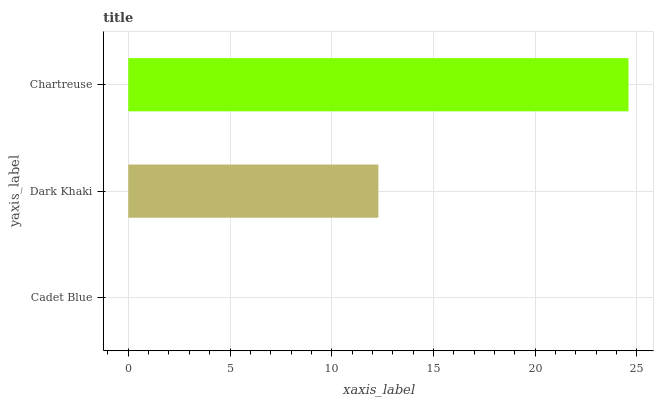Is Cadet Blue the minimum?
Answer yes or no. Yes. Is Chartreuse the maximum?
Answer yes or no. Yes. Is Dark Khaki the minimum?
Answer yes or no. No. Is Dark Khaki the maximum?
Answer yes or no. No. Is Dark Khaki greater than Cadet Blue?
Answer yes or no. Yes. Is Cadet Blue less than Dark Khaki?
Answer yes or no. Yes. Is Cadet Blue greater than Dark Khaki?
Answer yes or no. No. Is Dark Khaki less than Cadet Blue?
Answer yes or no. No. Is Dark Khaki the high median?
Answer yes or no. Yes. Is Dark Khaki the low median?
Answer yes or no. Yes. Is Cadet Blue the high median?
Answer yes or no. No. Is Cadet Blue the low median?
Answer yes or no. No. 